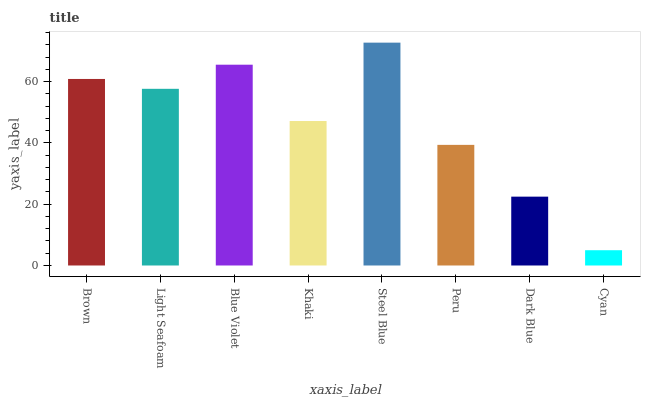Is Cyan the minimum?
Answer yes or no. Yes. Is Steel Blue the maximum?
Answer yes or no. Yes. Is Light Seafoam the minimum?
Answer yes or no. No. Is Light Seafoam the maximum?
Answer yes or no. No. Is Brown greater than Light Seafoam?
Answer yes or no. Yes. Is Light Seafoam less than Brown?
Answer yes or no. Yes. Is Light Seafoam greater than Brown?
Answer yes or no. No. Is Brown less than Light Seafoam?
Answer yes or no. No. Is Light Seafoam the high median?
Answer yes or no. Yes. Is Khaki the low median?
Answer yes or no. Yes. Is Dark Blue the high median?
Answer yes or no. No. Is Blue Violet the low median?
Answer yes or no. No. 